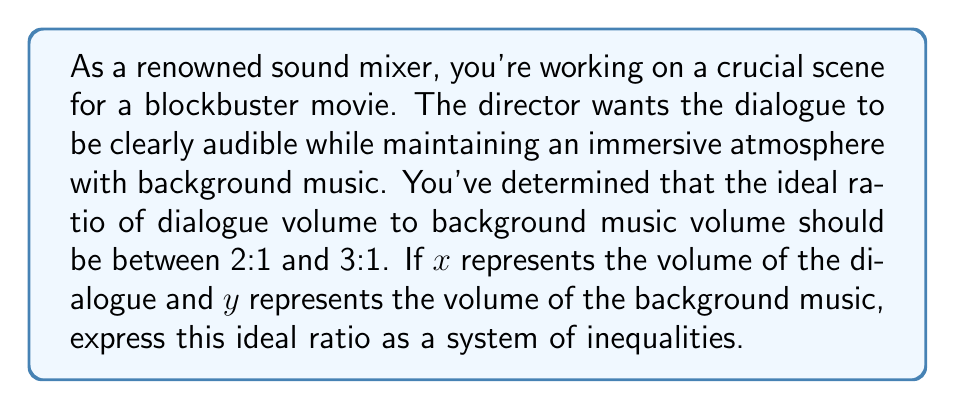Could you help me with this problem? To solve this problem, we need to translate the given ratio information into a system of inequalities. Let's approach this step-by-step:

1) The ratio of dialogue volume (x) to background music volume (y) should be between 2:1 and 3:1.

2) For the lower bound (2:1 ratio):
   $$\frac{x}{y} \geq 2$$

3) For the upper bound (3:1 ratio):
   $$\frac{x}{y} \leq 3$$

4) We can rewrite these inequalities to standard form:
   For the lower bound: $$x \geq 2y$$
   For the upper bound: $$x \leq 3y$$

5) Combining these inequalities, we get:
   $$2y \leq x \leq 3y$$

6) We can also add the constraint that both x and y must be positive, as negative volume doesn't make sense in this context:
   $$x > 0, y > 0$$

Therefore, the complete system of inequalities representing the ideal ratio is:
$$\begin{cases}
2y \leq x \leq 3y \\
x > 0 \\
y > 0
\end{cases}$$

This system of inequalities defines the region where the ratio of dialogue volume to background music volume is ideal according to the director's requirements.
Answer: $$\begin{cases}
2y \leq x \leq 3y \\
x > 0 \\
y > 0
\end{cases}$$ 